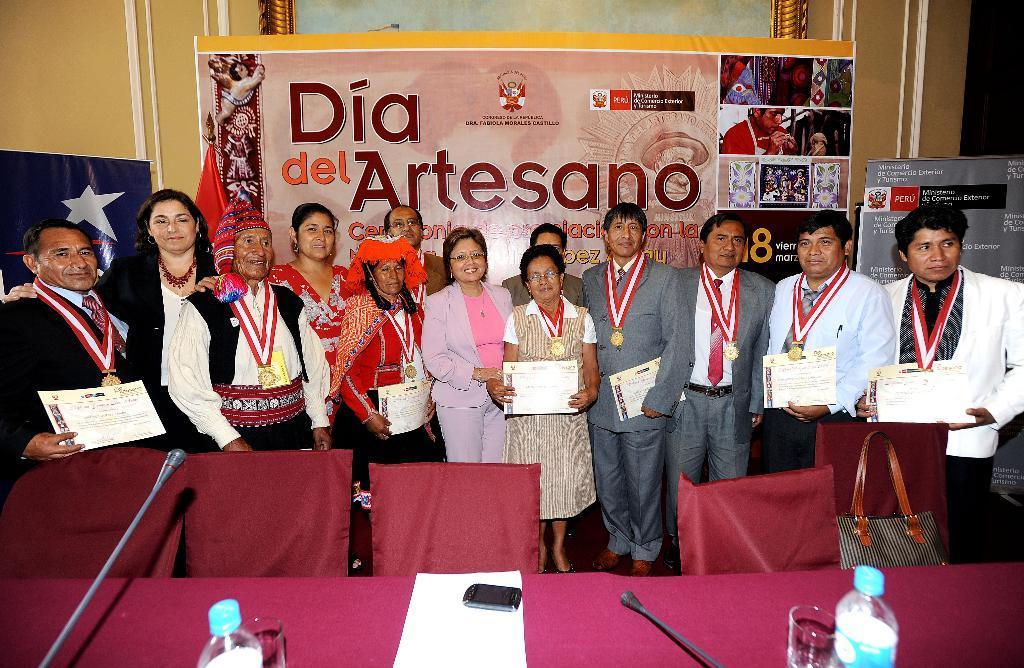How would you summarize this image in a sentence or two? In this picture we can see a group of people is standing on the path and holding certificates. In front of the people there are chairs, table and on the table there are glasses, bottles, paper, mobile and microphones. Behind the people there are banners and a wall. 